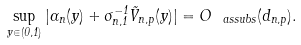<formula> <loc_0><loc_0><loc_500><loc_500>\sup _ { y \in ( 0 , 1 ) } | \alpha _ { n } ( y ) + \sigma _ { n , 1 } ^ { - 1 } \tilde { V } _ { n , p } ( y ) | = O _ { \ a s s u b s } ( d _ { n , p } ) .</formula> 